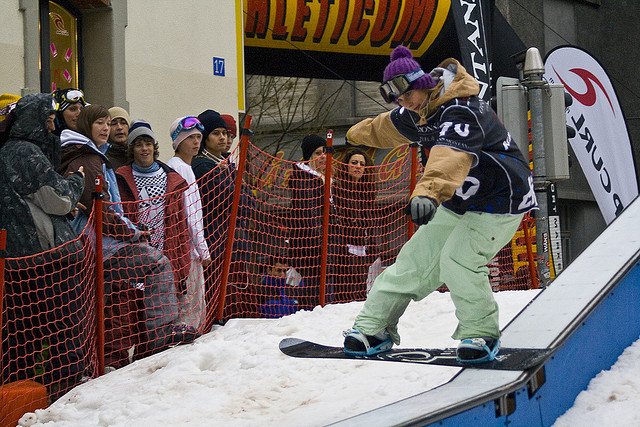<image>What is the name of the trick being performed in this photo? I don't know the name of the trick being performed in the photo. It could be 'boardslide', 'ollie', 'sliding', 'grind', 'basic jump' or 'rail slide'. What is the name of the trick being performed in this photo? I don't know what is the name of the trick being performed in this photo. It can be boardslide, ollie, sliding, grind, basic jump or rail slide. 